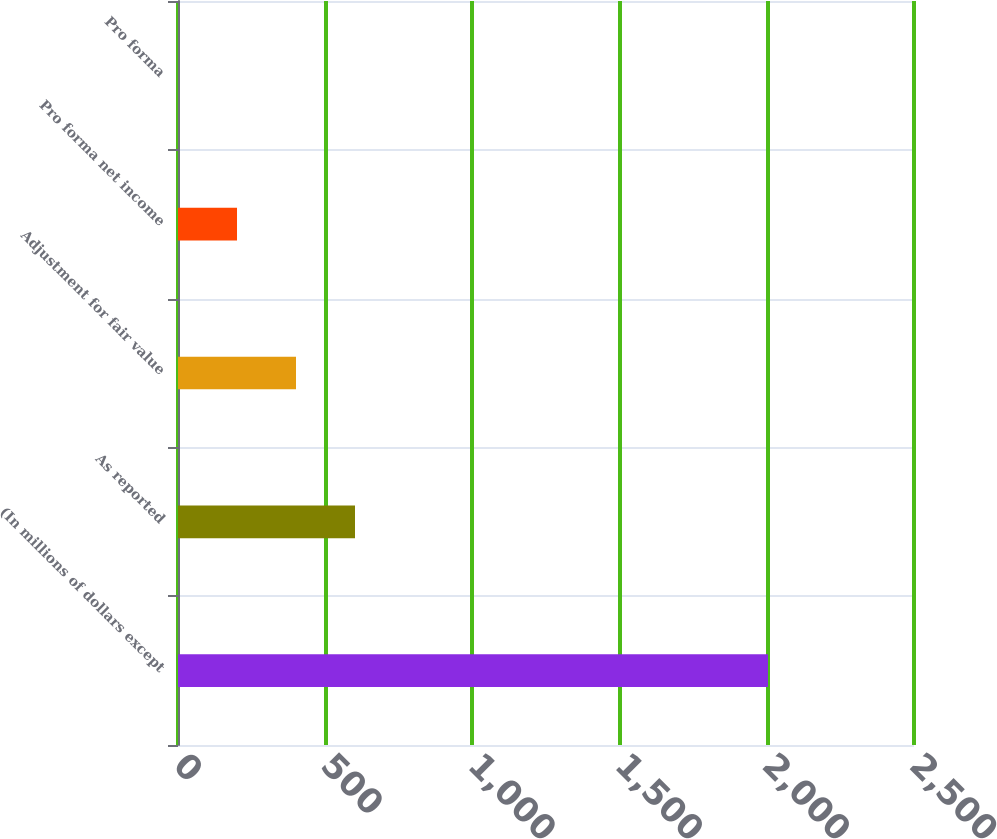Convert chart to OTSL. <chart><loc_0><loc_0><loc_500><loc_500><bar_chart><fcel>(In millions of dollars except<fcel>As reported<fcel>Adjustment for fair value<fcel>Pro forma net income<fcel>Pro forma<nl><fcel>2004<fcel>601.23<fcel>400.84<fcel>200.45<fcel>0.06<nl></chart> 